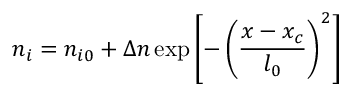Convert formula to latex. <formula><loc_0><loc_0><loc_500><loc_500>n _ { i } = n _ { i 0 } + \Delta n \exp \left [ - \left ( \frac { x - x _ { c } } { l _ { 0 } } \right ) ^ { 2 } \right ]</formula> 